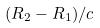<formula> <loc_0><loc_0><loc_500><loc_500>( R _ { 2 } - R _ { 1 } ) / c</formula> 